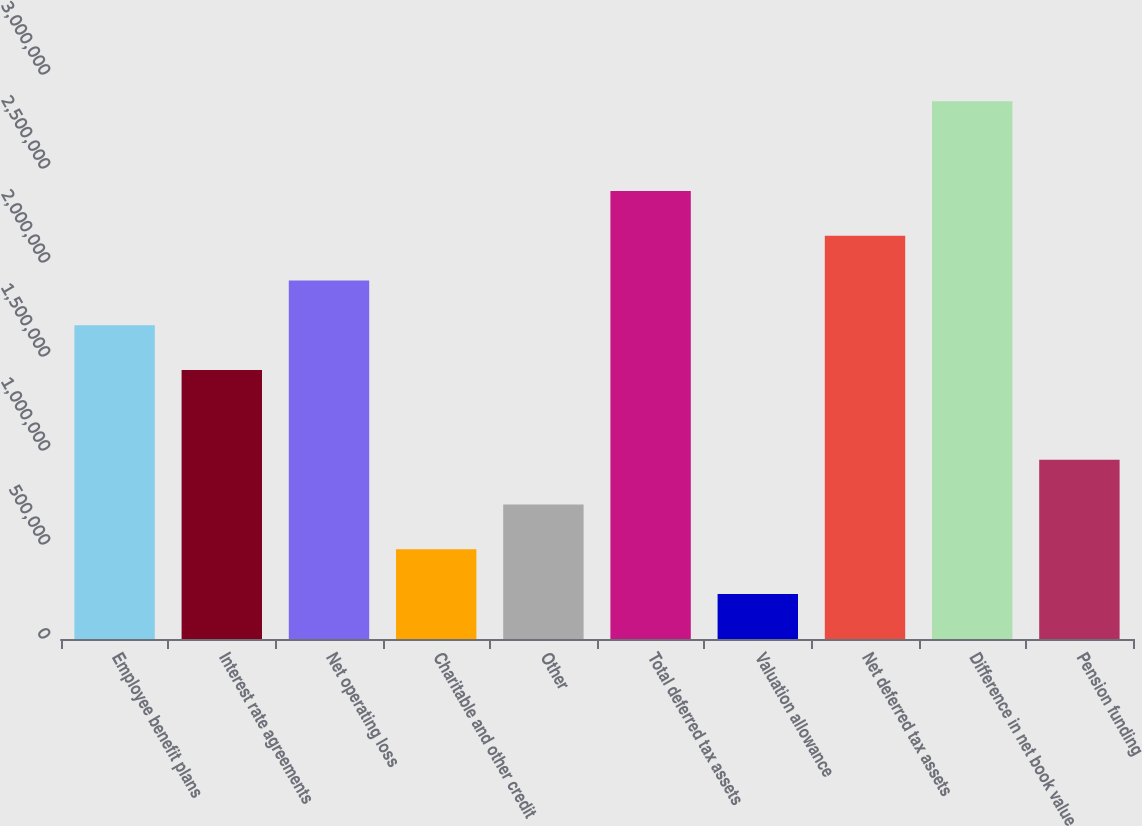Convert chart. <chart><loc_0><loc_0><loc_500><loc_500><bar_chart><fcel>Employee benefit plans<fcel>Interest rate agreements<fcel>Net operating loss<fcel>Charitable and other credit<fcel>Other<fcel>Total deferred tax assets<fcel>Valuation allowance<fcel>Net deferred tax assets<fcel>Difference in net book value<fcel>Pension funding<nl><fcel>1.6686e+06<fcel>1.43036e+06<fcel>1.90685e+06<fcel>477359<fcel>715608<fcel>2.38335e+06<fcel>239110<fcel>2.1451e+06<fcel>2.85985e+06<fcel>953857<nl></chart> 